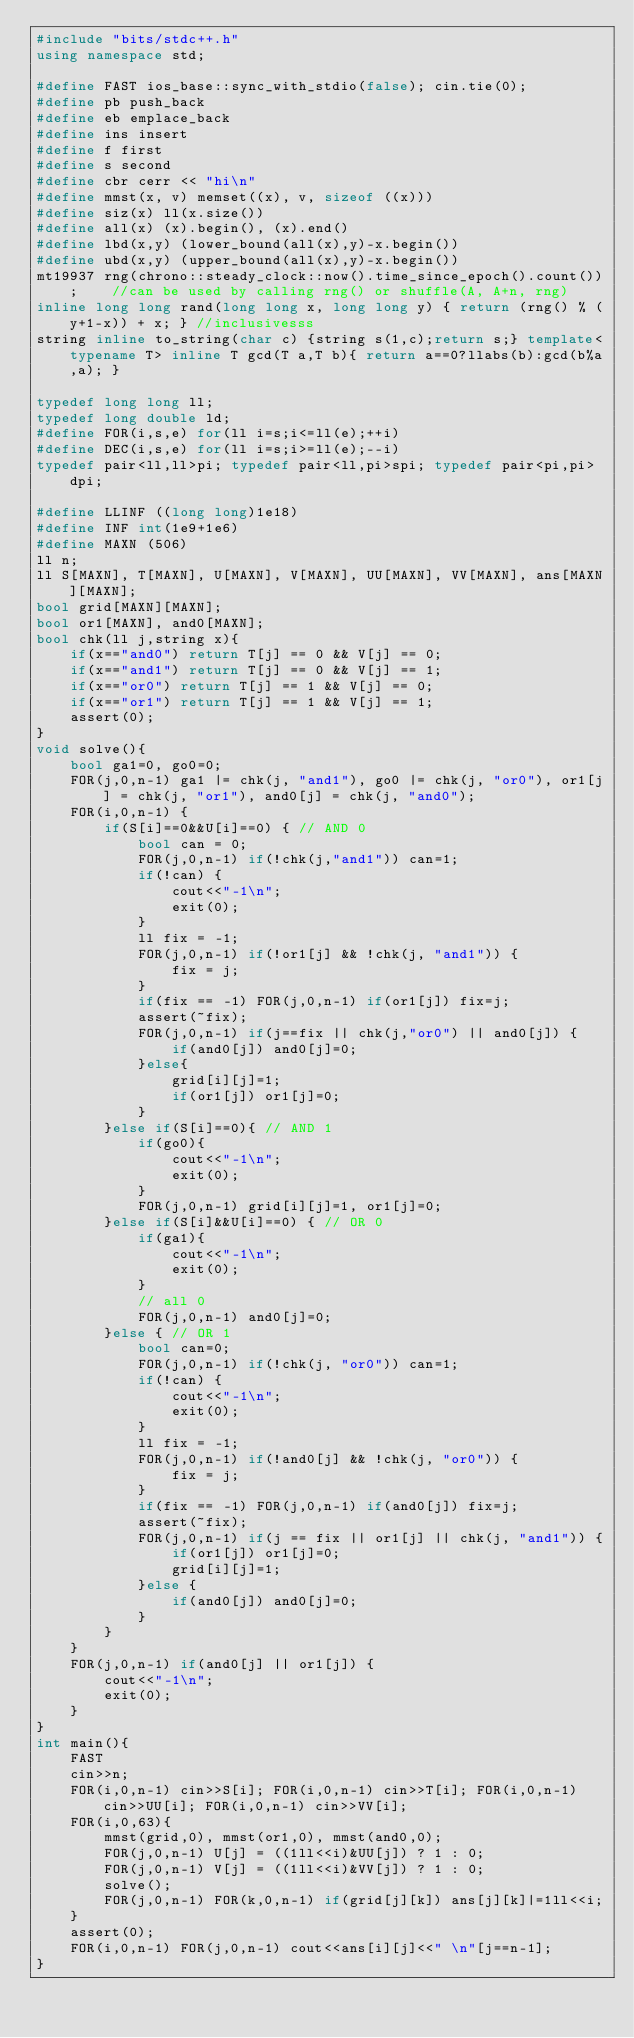<code> <loc_0><loc_0><loc_500><loc_500><_C++_>#include "bits/stdc++.h"
using namespace std;

#define FAST ios_base::sync_with_stdio(false); cin.tie(0);
#define pb push_back
#define eb emplace_back
#define ins insert
#define f first
#define s second
#define cbr cerr << "hi\n"
#define mmst(x, v) memset((x), v, sizeof ((x)))
#define siz(x) ll(x.size())
#define all(x) (x).begin(), (x).end()
#define lbd(x,y) (lower_bound(all(x),y)-x.begin())
#define ubd(x,y) (upper_bound(all(x),y)-x.begin())
mt19937 rng(chrono::steady_clock::now().time_since_epoch().count());    //can be used by calling rng() or shuffle(A, A+n, rng)
inline long long rand(long long x, long long y) { return (rng() % (y+1-x)) + x; } //inclusivesss
string inline to_string(char c) {string s(1,c);return s;} template<typename T> inline T gcd(T a,T b){ return a==0?llabs(b):gcd(b%a,a); }

typedef long long ll; 
typedef long double ld;
#define FOR(i,s,e) for(ll i=s;i<=ll(e);++i)
#define DEC(i,s,e) for(ll i=s;i>=ll(e);--i)
typedef pair<ll,ll>pi; typedef pair<ll,pi>spi; typedef pair<pi,pi>dpi;

#define LLINF ((long long)1e18)
#define INF int(1e9+1e6)
#define MAXN (506)
ll n;
ll S[MAXN], T[MAXN], U[MAXN], V[MAXN], UU[MAXN], VV[MAXN], ans[MAXN][MAXN];
bool grid[MAXN][MAXN];
bool or1[MAXN], and0[MAXN];
bool chk(ll j,string x){
	if(x=="and0") return T[j] == 0 && V[j] == 0;
	if(x=="and1") return T[j] == 0 && V[j] == 1;
	if(x=="or0") return T[j] == 1 && V[j] == 0;
	if(x=="or1") return T[j] == 1 && V[j] == 1;
	assert(0);
}
void solve(){
	bool ga1=0, go0=0;
	FOR(j,0,n-1) ga1 |= chk(j, "and1"), go0 |= chk(j, "or0"), or1[j] = chk(j, "or1"), and0[j] = chk(j, "and0");
	FOR(i,0,n-1) {
		if(S[i]==0&&U[i]==0) { // AND 0
			bool can = 0;
			FOR(j,0,n-1) if(!chk(j,"and1")) can=1;
			if(!can) {
				cout<<"-1\n";
				exit(0);
			}
			ll fix = -1;
			FOR(j,0,n-1) if(!or1[j] && !chk(j, "and1")) {
				fix = j;
			}
			if(fix == -1) FOR(j,0,n-1) if(or1[j]) fix=j;
			assert(~fix);
			FOR(j,0,n-1) if(j==fix || chk(j,"or0") || and0[j]) {
				if(and0[j]) and0[j]=0;
			}else{
				grid[i][j]=1;
				if(or1[j]) or1[j]=0;
			}
		}else if(S[i]==0){ // AND 1
			if(go0){
				cout<<"-1\n";
				exit(0);
			}
			FOR(j,0,n-1) grid[i][j]=1, or1[j]=0;
		}else if(S[i]&&U[i]==0) { // OR 0
			if(ga1){
				cout<<"-1\n";
				exit(0);
			}
			// all 0
			FOR(j,0,n-1) and0[j]=0;
		}else { // OR 1
			bool can=0;
			FOR(j,0,n-1) if(!chk(j, "or0")) can=1;
			if(!can) {
				cout<<"-1\n";
				exit(0);
			}
			ll fix = -1;
			FOR(j,0,n-1) if(!and0[j] && !chk(j, "or0")) {
				fix = j;
			}
			if(fix == -1) FOR(j,0,n-1) if(and0[j]) fix=j;
			assert(~fix);
			FOR(j,0,n-1) if(j == fix || or1[j] || chk(j, "and1")) {
				if(or1[j]) or1[j]=0;
				grid[i][j]=1;
			}else {
				if(and0[j]) and0[j]=0;
			}
		}
	}
	FOR(j,0,n-1) if(and0[j] || or1[j]) {
		cout<<"-1\n";
		exit(0);
	}
}
int main(){
	FAST
	cin>>n;
	FOR(i,0,n-1) cin>>S[i]; FOR(i,0,n-1) cin>>T[i]; FOR(i,0,n-1) cin>>UU[i]; FOR(i,0,n-1) cin>>VV[i];
	FOR(i,0,63){
		mmst(grid,0), mmst(or1,0), mmst(and0,0);
		FOR(j,0,n-1) U[j] = ((1ll<<i)&UU[j]) ? 1 : 0;
		FOR(j,0,n-1) V[j] = ((1ll<<i)&VV[j]) ? 1 : 0;
		solve();
		FOR(j,0,n-1) FOR(k,0,n-1) if(grid[j][k]) ans[j][k]|=1ll<<i;
	}
	assert(0);
	FOR(i,0,n-1) FOR(j,0,n-1) cout<<ans[i][j]<<" \n"[j==n-1];
}
</code> 